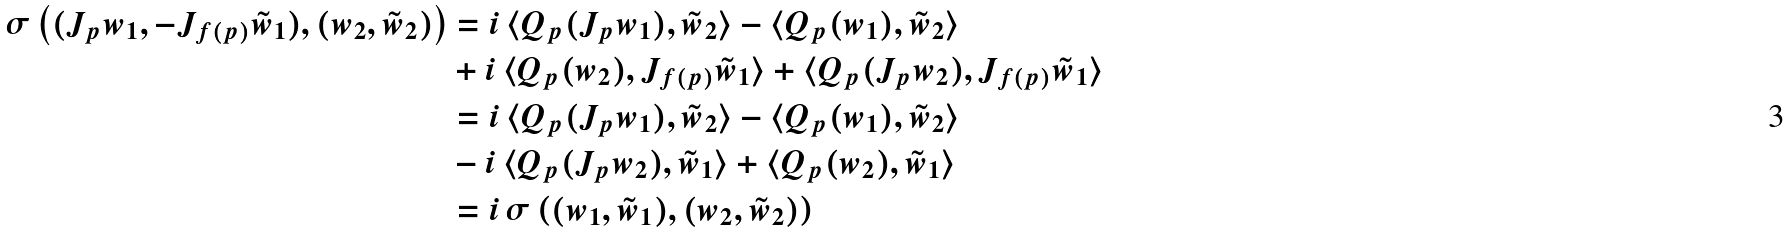<formula> <loc_0><loc_0><loc_500><loc_500>\sigma \left ( ( J _ { p } w _ { 1 } , - J _ { f ( p ) } \tilde { w } _ { 1 } ) , ( w _ { 2 } , \tilde { w } _ { 2 } ) \right ) & = i \, \langle Q _ { p } ( J _ { p } w _ { 1 } ) , \tilde { w } _ { 2 } \rangle - \langle Q _ { p } ( w _ { 1 } ) , \tilde { w } _ { 2 } \rangle \\ & + i \, \langle Q _ { p } ( w _ { 2 } ) , J _ { f ( p ) } \tilde { w } _ { 1 } \rangle + \langle Q _ { p } ( J _ { p } w _ { 2 } ) , J _ { f ( p ) } \tilde { w } _ { 1 } \rangle \\ & = i \, \langle Q _ { p } ( J _ { p } w _ { 1 } ) , \tilde { w } _ { 2 } \rangle - \langle Q _ { p } ( w _ { 1 } ) , \tilde { w } _ { 2 } \rangle \\ & - i \, \langle Q _ { p } ( J _ { p } w _ { 2 } ) , \tilde { w } _ { 1 } \rangle + \langle Q _ { p } ( w _ { 2 } ) , \tilde { w } _ { 1 } \rangle \\ & = i \, \sigma \left ( ( w _ { 1 } , \tilde { w } _ { 1 } ) , ( w _ { 2 } , \tilde { w } _ { 2 } ) \right )</formula> 